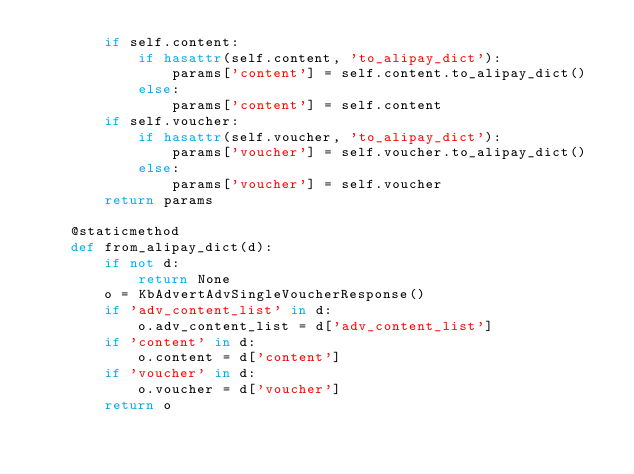<code> <loc_0><loc_0><loc_500><loc_500><_Python_>        if self.content:
            if hasattr(self.content, 'to_alipay_dict'):
                params['content'] = self.content.to_alipay_dict()
            else:
                params['content'] = self.content
        if self.voucher:
            if hasattr(self.voucher, 'to_alipay_dict'):
                params['voucher'] = self.voucher.to_alipay_dict()
            else:
                params['voucher'] = self.voucher
        return params

    @staticmethod
    def from_alipay_dict(d):
        if not d:
            return None
        o = KbAdvertAdvSingleVoucherResponse()
        if 'adv_content_list' in d:
            o.adv_content_list = d['adv_content_list']
        if 'content' in d:
            o.content = d['content']
        if 'voucher' in d:
            o.voucher = d['voucher']
        return o


</code> 